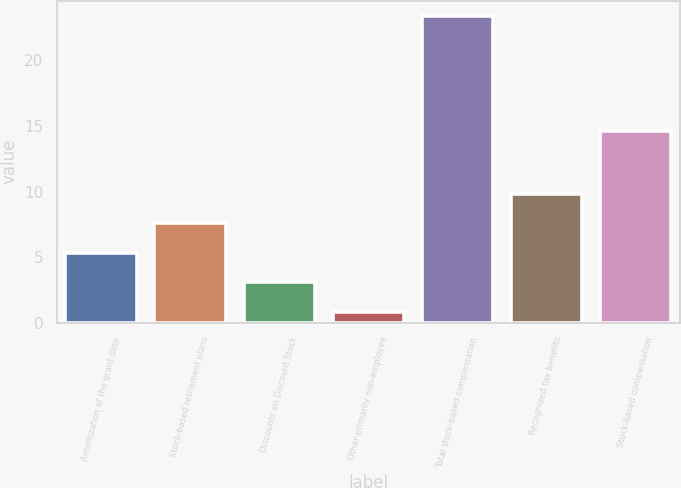Convert chart to OTSL. <chart><loc_0><loc_0><loc_500><loc_500><bar_chart><fcel>Amortization of the grant date<fcel>Stock-based retirement plans<fcel>Discounts on Discount Stock<fcel>Other primarily non-employee<fcel>Total stock-based compensation<fcel>Recognized tax benefits<fcel>Stock-based compensation<nl><fcel>5.32<fcel>7.58<fcel>3.06<fcel>0.8<fcel>23.4<fcel>9.84<fcel>14.6<nl></chart> 